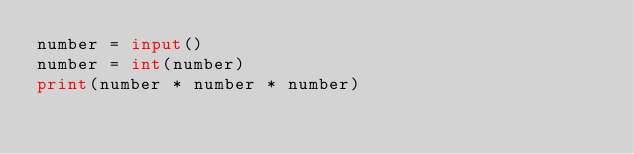Convert code to text. <code><loc_0><loc_0><loc_500><loc_500><_Python_>number = input()
number = int(number)
print(number * number * number)</code> 